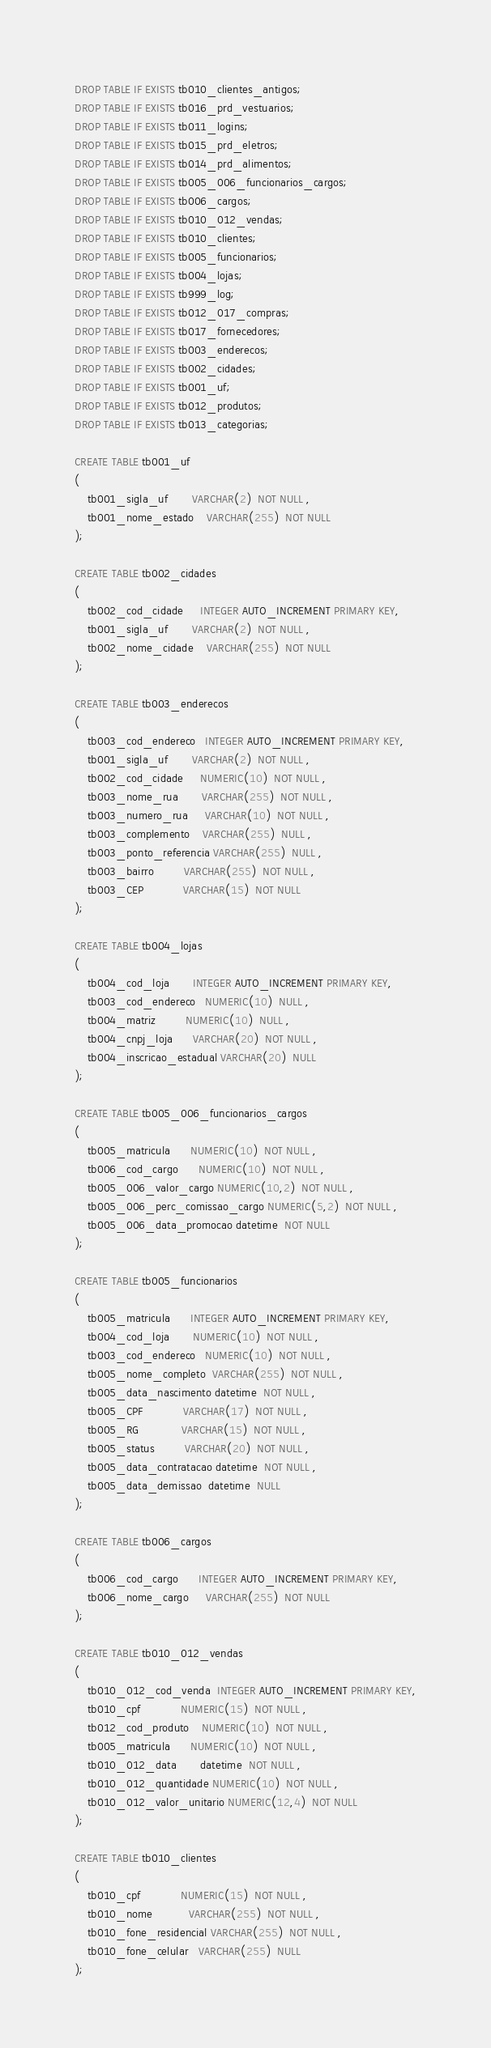Convert code to text. <code><loc_0><loc_0><loc_500><loc_500><_SQL_>DROP TABLE IF EXISTS tb010_clientes_antigos;
DROP TABLE IF EXISTS tb016_prd_vestuarios;
DROP TABLE IF EXISTS tb011_logins;
DROP TABLE IF EXISTS tb015_prd_eletros;
DROP TABLE IF EXISTS tb014_prd_alimentos;
DROP TABLE IF EXISTS tb005_006_funcionarios_cargos;
DROP TABLE IF EXISTS tb006_cargos;
DROP TABLE IF EXISTS tb010_012_vendas;
DROP TABLE IF EXISTS tb010_clientes;
DROP TABLE IF EXISTS tb005_funcionarios;
DROP TABLE IF EXISTS tb004_lojas;
DROP TABLE IF EXISTS tb999_log;
DROP TABLE IF EXISTS tb012_017_compras;
DROP TABLE IF EXISTS tb017_fornecedores;
DROP TABLE IF EXISTS tb003_enderecos;
DROP TABLE IF EXISTS tb002_cidades;
DROP TABLE IF EXISTS tb001_uf;
DROP TABLE IF EXISTS tb012_produtos;
DROP TABLE IF EXISTS tb013_categorias;

CREATE TABLE tb001_uf
( 
	tb001_sigla_uf       VARCHAR(2)  NOT NULL ,
	tb001_nome_estado    VARCHAR(255)  NOT NULL 
);

CREATE TABLE tb002_cidades
( 
	tb002_cod_cidade     INTEGER AUTO_INCREMENT PRIMARY KEY,
	tb001_sigla_uf       VARCHAR(2)  NOT NULL ,
	tb002_nome_cidade    VARCHAR(255)  NOT NULL 
);

CREATE TABLE tb003_enderecos
( 
	tb003_cod_endereco   INTEGER AUTO_INCREMENT PRIMARY KEY,
	tb001_sigla_uf       VARCHAR(2)  NOT NULL ,
	tb002_cod_cidade     NUMERIC(10)  NOT NULL ,
	tb003_nome_rua       VARCHAR(255)  NOT NULL ,
	tb003_numero_rua     VARCHAR(10)  NOT NULL ,
	tb003_complemento    VARCHAR(255)  NULL ,
	tb003_ponto_referencia VARCHAR(255)  NULL ,
	tb003_bairro         VARCHAR(255)  NOT NULL ,
	tb003_CEP            VARCHAR(15)  NOT NULL 
);

CREATE TABLE tb004_lojas
( 
	tb004_cod_loja       INTEGER AUTO_INCREMENT PRIMARY KEY,
	tb003_cod_endereco   NUMERIC(10)  NULL ,
	tb004_matriz         NUMERIC(10)  NULL ,
	tb004_cnpj_loja      VARCHAR(20)  NOT NULL ,
	tb004_inscricao_estadual VARCHAR(20)  NULL 
);

CREATE TABLE tb005_006_funcionarios_cargos
( 
	tb005_matricula      NUMERIC(10)  NOT NULL ,
	tb006_cod_cargo      NUMERIC(10)  NOT NULL ,
	tb005_006_valor_cargo NUMERIC(10,2)  NOT NULL ,
	tb005_006_perc_comissao_cargo NUMERIC(5,2)  NOT NULL ,
	tb005_006_data_promocao datetime  NOT NULL 
);

CREATE TABLE tb005_funcionarios
( 
	tb005_matricula      INTEGER AUTO_INCREMENT PRIMARY KEY,
	tb004_cod_loja       NUMERIC(10)  NOT NULL ,
	tb003_cod_endereco   NUMERIC(10)  NOT NULL ,
	tb005_nome_completo  VARCHAR(255)  NOT NULL ,
	tb005_data_nascimento datetime  NOT NULL ,
	tb005_CPF            VARCHAR(17)  NOT NULL ,
	tb005_RG             VARCHAR(15)  NOT NULL ,
	tb005_status         VARCHAR(20)  NOT NULL ,
	tb005_data_contratacao datetime  NOT NULL ,
	tb005_data_demissao  datetime  NULL 
);

CREATE TABLE tb006_cargos
( 
	tb006_cod_cargo      INTEGER AUTO_INCREMENT PRIMARY KEY,
	tb006_nome_cargo     VARCHAR(255)  NOT NULL 
);

CREATE TABLE tb010_012_vendas
( 
	tb010_012_cod_venda  INTEGER AUTO_INCREMENT PRIMARY KEY,
	tb010_cpf            NUMERIC(15)  NOT NULL ,
	tb012_cod_produto    NUMERIC(10)  NOT NULL ,
	tb005_matricula      NUMERIC(10)  NOT NULL ,
	tb010_012_data       datetime  NOT NULL ,
	tb010_012_quantidade NUMERIC(10)  NOT NULL ,
	tb010_012_valor_unitario NUMERIC(12,4)  NOT NULL
);

CREATE TABLE tb010_clientes
( 
	tb010_cpf            NUMERIC(15)  NOT NULL ,
	tb010_nome           VARCHAR(255)  NOT NULL ,
	tb010_fone_residencial VARCHAR(255)  NOT NULL ,
	tb010_fone_celular   VARCHAR(255)  NULL 
);
</code> 